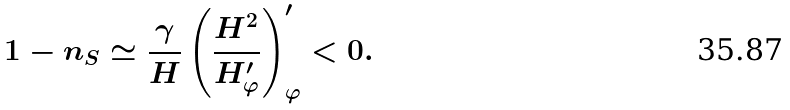Convert formula to latex. <formula><loc_0><loc_0><loc_500><loc_500>1 - n _ { S } \simeq \frac { \gamma } { H } \left ( \frac { H ^ { 2 } } { H ^ { \prime } _ { \varphi } } \right ) ^ { \prime } _ { \varphi } < 0 .</formula> 